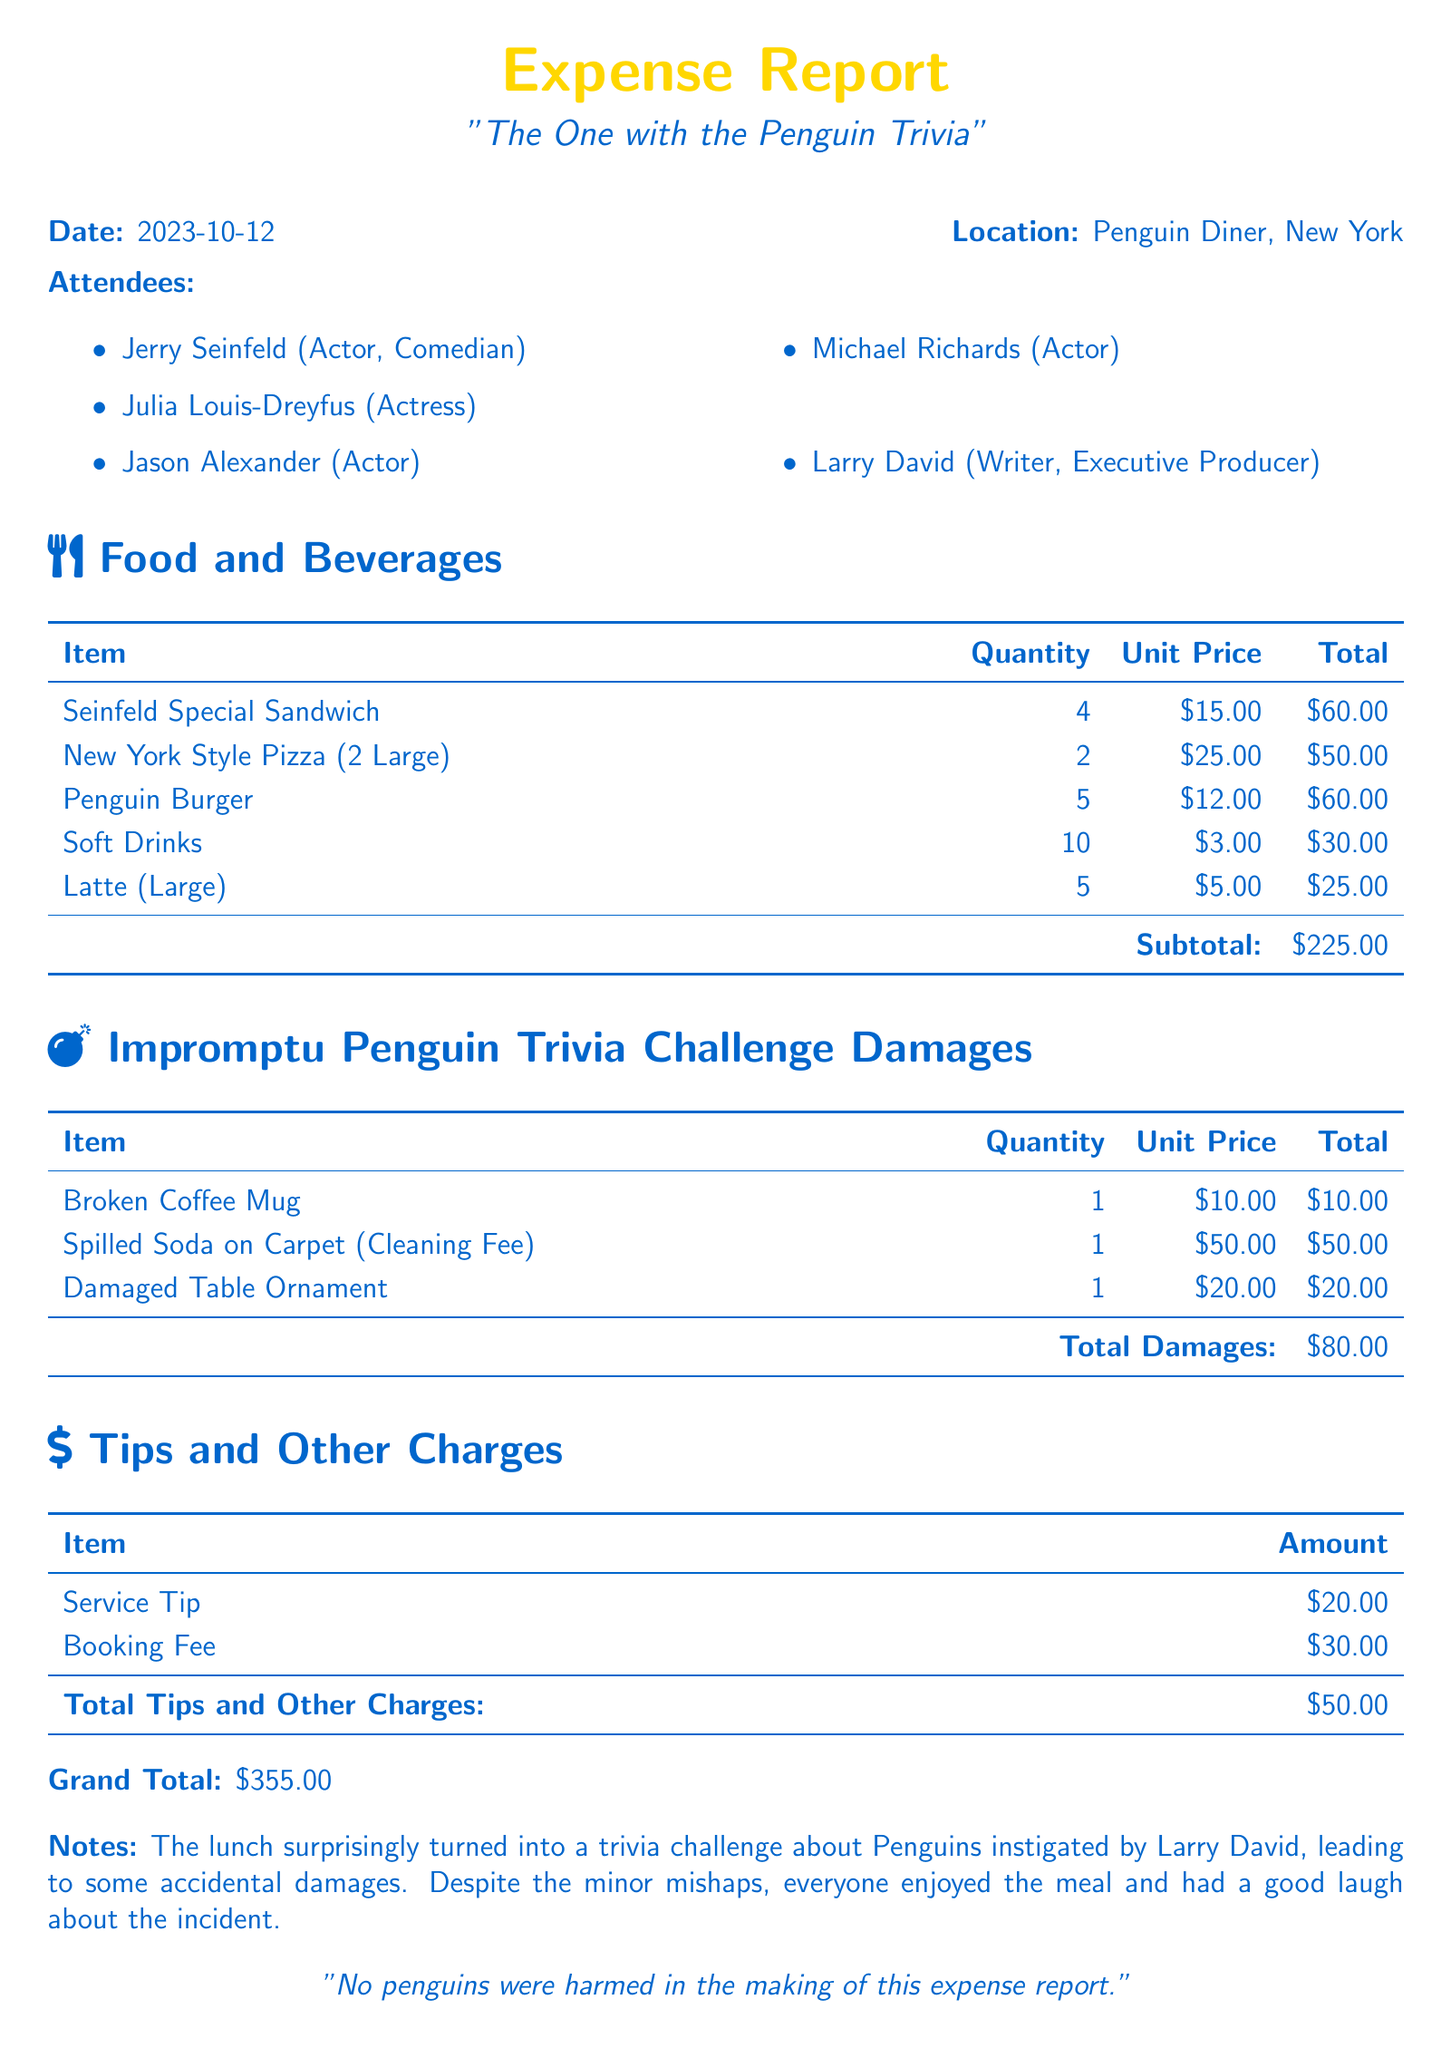What is the total amount spent on food and beverages? The total for food and beverages is specified in the subtotal section of the report, which is $225.00.
Answer: $225.00 What item had the highest quantity ordered? The item with the highest quantity is the Penguin Burger, which was ordered 5 times.
Answer: Penguin Burger What was the date of the team lunch? The document provides the date of the lunch as noted in the header section, which is 2023-10-12.
Answer: 2023-10-12 How much was the cleaning fee for the spilled soda? The cleaning fee for the spilled soda is listed in the damages section as $50.00.
Answer: $50.00 What was the total amount charged for tips and other charges? The document states that the total for tips and other charges at the end of the relevant section is $50.00.
Answer: $50.00 What is the grand total of the expenses? The grand total, which includes food, damages, and tips, is listed at the bottom of the document, amounting to $355.00.
Answer: $355.00 Who instigated the impromptu Penguin trivia challenge? The notes section mentions that Larry David instigated the trivia challenge about Penguins.
Answer: Larry David How many attendees were present at the lunch? The list of attendees enumerates five people who were present at the lunch.
Answer: 5 